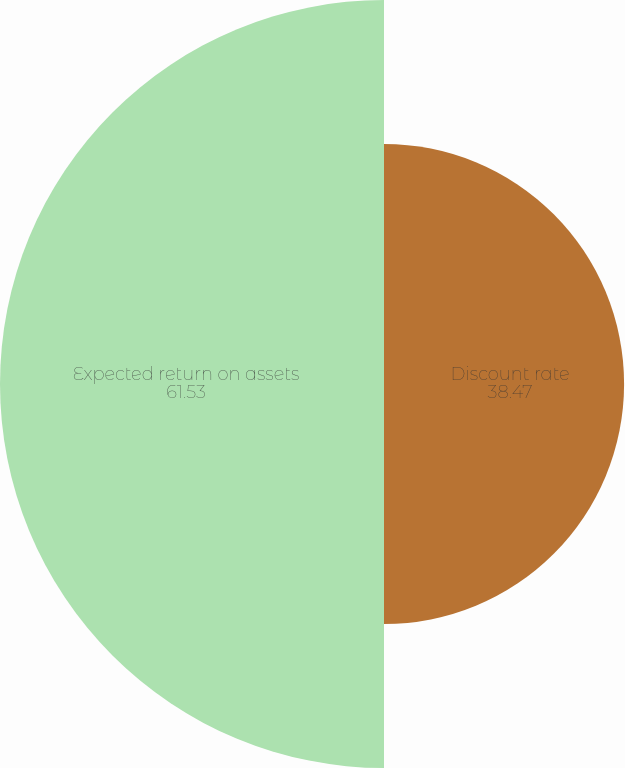<chart> <loc_0><loc_0><loc_500><loc_500><pie_chart><fcel>Discount rate<fcel>Expected return on assets<nl><fcel>38.47%<fcel>61.53%<nl></chart> 